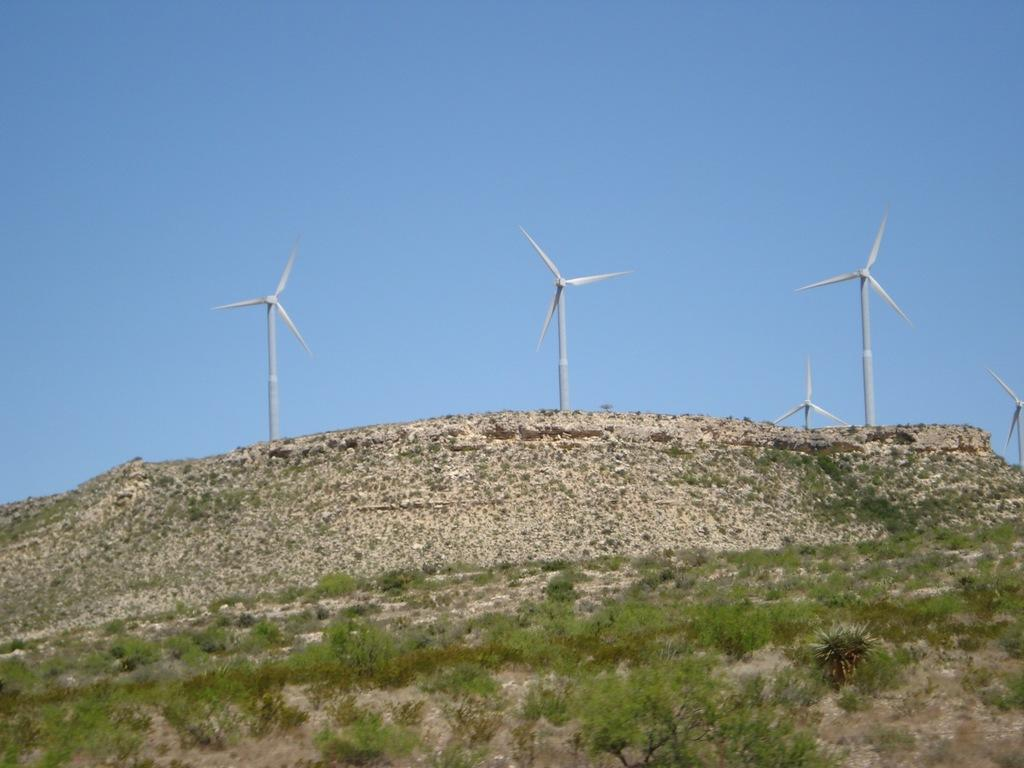What type of vegetation is at the bottom of the image? There is grass at the bottom of the image. What structures can be seen in the background of the image? There are wind turbines in the background of the image. What is visible at the top of the image? The sky is visible at the top of the image. How does the grass tie a knot in the image? There is no knot-tying activity involving grass in the image. Grass is simply a type of vegetation at the bottom of the image. 